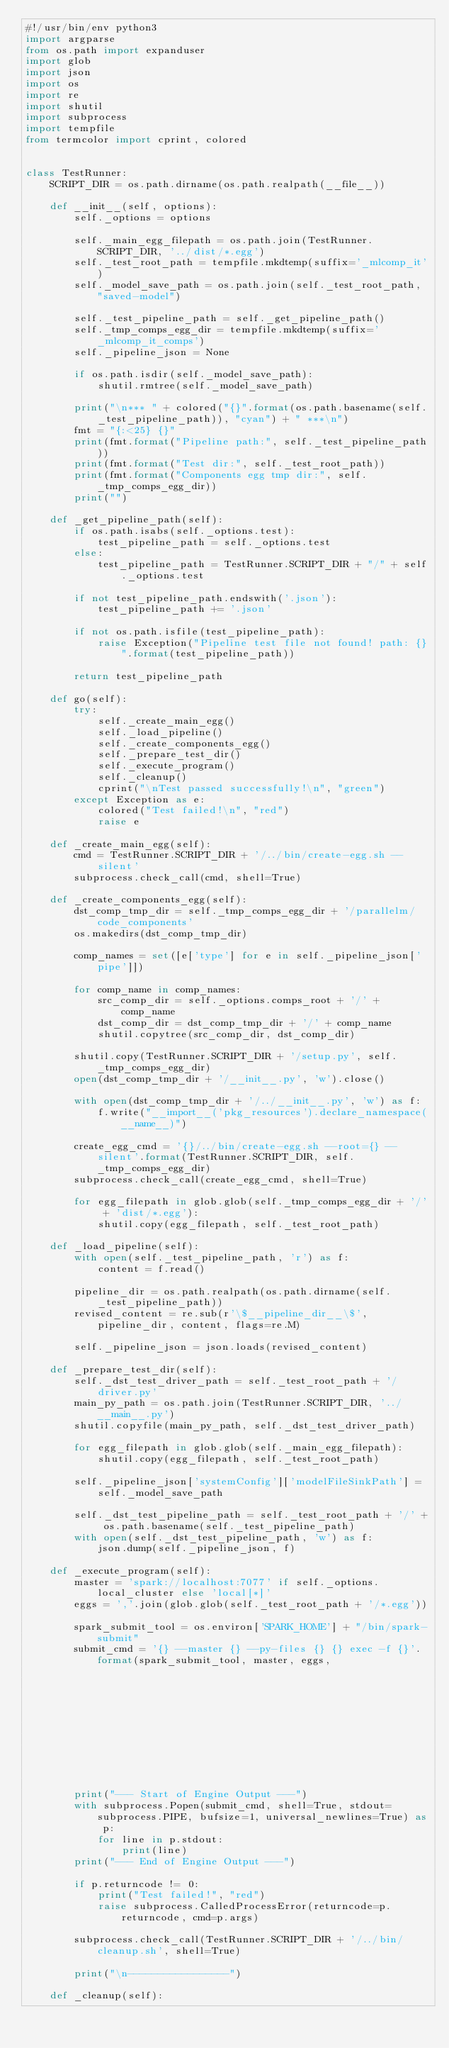<code> <loc_0><loc_0><loc_500><loc_500><_Python_>#!/usr/bin/env python3
import argparse
from os.path import expanduser
import glob
import json
import os
import re
import shutil
import subprocess
import tempfile
from termcolor import cprint, colored


class TestRunner:
    SCRIPT_DIR = os.path.dirname(os.path.realpath(__file__))

    def __init__(self, options):
        self._options = options

        self._main_egg_filepath = os.path.join(TestRunner.SCRIPT_DIR, '../dist/*.egg')
        self._test_root_path = tempfile.mkdtemp(suffix='_mlcomp_it')
        self._model_save_path = os.path.join(self._test_root_path, "saved-model")

        self._test_pipeline_path = self._get_pipeline_path()
        self._tmp_comps_egg_dir = tempfile.mkdtemp(suffix='_mlcomp_it_comps')
        self._pipeline_json = None

        if os.path.isdir(self._model_save_path):
            shutil.rmtree(self._model_save_path)

        print("\n*** " + colored("{}".format(os.path.basename(self._test_pipeline_path)), "cyan") + " ***\n")
        fmt = "{:<25} {}"
        print(fmt.format("Pipeline path:", self._test_pipeline_path))
        print(fmt.format("Test dir:", self._test_root_path))
        print(fmt.format("Components egg tmp dir:", self._tmp_comps_egg_dir))
        print("")

    def _get_pipeline_path(self):
        if os.path.isabs(self._options.test):
            test_pipeline_path = self._options.test
        else:
            test_pipeline_path = TestRunner.SCRIPT_DIR + "/" + self._options.test

        if not test_pipeline_path.endswith('.json'):
            test_pipeline_path += '.json'

        if not os.path.isfile(test_pipeline_path):
            raise Exception("Pipeline test file not found! path: {}".format(test_pipeline_path))

        return test_pipeline_path

    def go(self):
        try:
            self._create_main_egg()
            self._load_pipeline()
            self._create_components_egg()
            self._prepare_test_dir()
            self._execute_program()
            self._cleanup()
            cprint("\nTest passed successfully!\n", "green")
        except Exception as e:
            colored("Test failed!\n", "red")
            raise e

    def _create_main_egg(self):
        cmd = TestRunner.SCRIPT_DIR + '/../bin/create-egg.sh --silent'
        subprocess.check_call(cmd, shell=True)

    def _create_components_egg(self):
        dst_comp_tmp_dir = self._tmp_comps_egg_dir + '/parallelm/code_components'
        os.makedirs(dst_comp_tmp_dir)

        comp_names = set([e['type'] for e in self._pipeline_json['pipe']])

        for comp_name in comp_names:
            src_comp_dir = self._options.comps_root + '/' + comp_name
            dst_comp_dir = dst_comp_tmp_dir + '/' + comp_name
            shutil.copytree(src_comp_dir, dst_comp_dir)

        shutil.copy(TestRunner.SCRIPT_DIR + '/setup.py', self._tmp_comps_egg_dir)
        open(dst_comp_tmp_dir + '/__init__.py', 'w').close()

        with open(dst_comp_tmp_dir + '/../__init__.py', 'w') as f:
            f.write("__import__('pkg_resources').declare_namespace(__name__)")

        create_egg_cmd = '{}/../bin/create-egg.sh --root={} --silent'.format(TestRunner.SCRIPT_DIR, self._tmp_comps_egg_dir)
        subprocess.check_call(create_egg_cmd, shell=True)

        for egg_filepath in glob.glob(self._tmp_comps_egg_dir + '/' + 'dist/*.egg'):
            shutil.copy(egg_filepath, self._test_root_path)

    def _load_pipeline(self):
        with open(self._test_pipeline_path, 'r') as f:
            content = f.read()

        pipeline_dir = os.path.realpath(os.path.dirname(self._test_pipeline_path))
        revised_content = re.sub(r'\$__pipeline_dir__\$', pipeline_dir, content, flags=re.M)

        self._pipeline_json = json.loads(revised_content)

    def _prepare_test_dir(self):
        self._dst_test_driver_path = self._test_root_path + '/driver.py'
        main_py_path = os.path.join(TestRunner.SCRIPT_DIR, '../__main__.py')
        shutil.copyfile(main_py_path, self._dst_test_driver_path)

        for egg_filepath in glob.glob(self._main_egg_filepath):
            shutil.copy(egg_filepath, self._test_root_path)

        self._pipeline_json['systemConfig']['modelFileSinkPath'] = self._model_save_path

        self._dst_test_pipeline_path = self._test_root_path + '/' + os.path.basename(self._test_pipeline_path)
        with open(self._dst_test_pipeline_path, 'w') as f:
            json.dump(self._pipeline_json, f)

    def _execute_program(self):
        master = 'spark://localhost:7077' if self._options.local_cluster else 'local[*]'
        eggs = ','.join(glob.glob(self._test_root_path + '/*.egg'))

        spark_submit_tool = os.environ['SPARK_HOME'] + "/bin/spark-submit"
        submit_cmd = '{} --master {} --py-files {} {} exec -f {}'.format(spark_submit_tool, master, eggs,
                                                                         self._dst_test_driver_path,
                                                                         self._dst_test_pipeline_path)

        print("--- Start of Engine Output ---")
        with subprocess.Popen(submit_cmd, shell=True, stdout=subprocess.PIPE, bufsize=1, universal_newlines=True) as p:
            for line in p.stdout:
                print(line)
        print("--- End of Engine Output ---")

        if p.returncode != 0:
            print("Test failed!", "red")
            raise subprocess.CalledProcessError(returncode=p.returncode, cmd=p.args)

        subprocess.check_call(TestRunner.SCRIPT_DIR + '/../bin/cleanup.sh', shell=True)

        print("\n-----------------")

    def _cleanup(self):</code> 